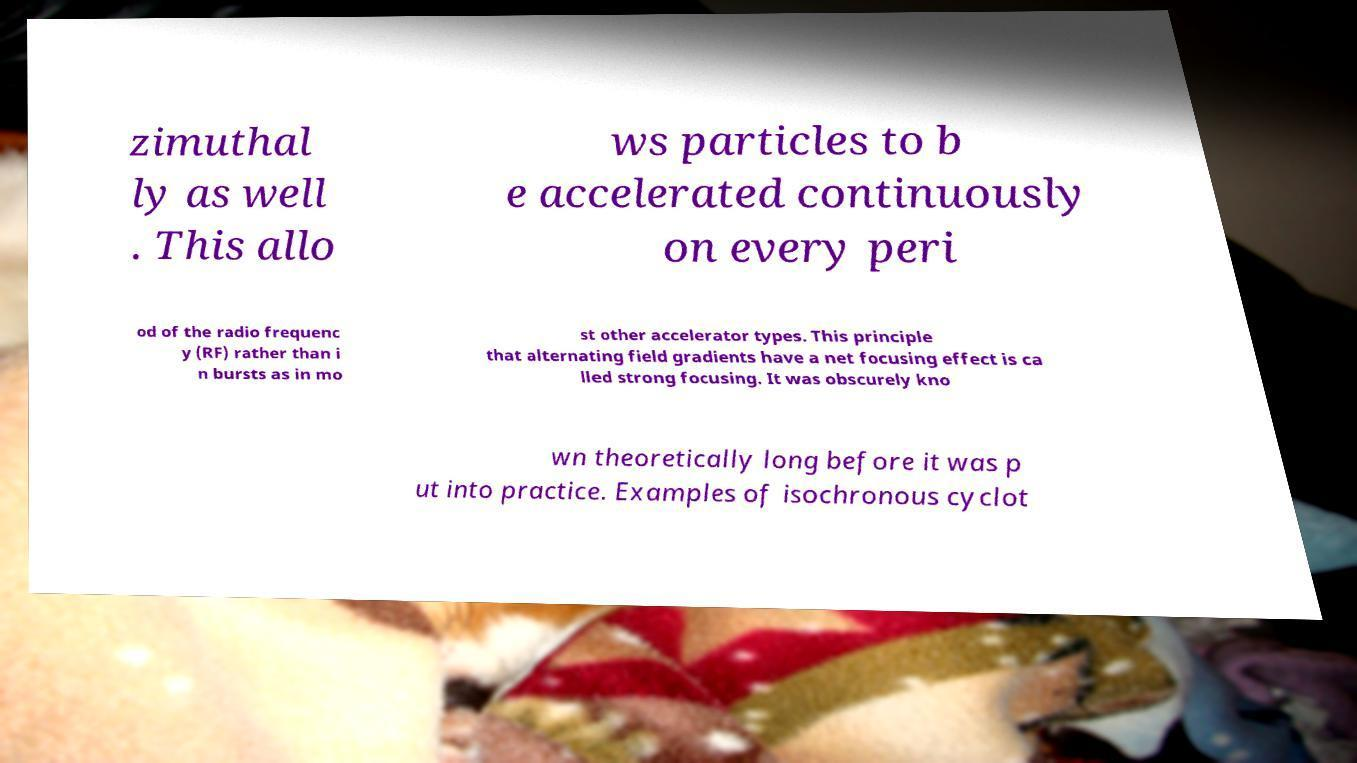Can you read and provide the text displayed in the image?This photo seems to have some interesting text. Can you extract and type it out for me? zimuthal ly as well . This allo ws particles to b e accelerated continuously on every peri od of the radio frequenc y (RF) rather than i n bursts as in mo st other accelerator types. This principle that alternating field gradients have a net focusing effect is ca lled strong focusing. It was obscurely kno wn theoretically long before it was p ut into practice. Examples of isochronous cyclot 